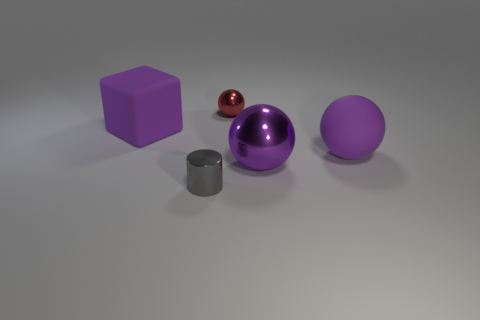What number of large purple objects are the same shape as the red metal thing?
Make the answer very short. 2. What is the thing left of the cylinder made of?
Your answer should be very brief. Rubber. There is a tiny metal thing behind the cylinder; is it the same shape as the big purple shiny object?
Offer a terse response. Yes. Are there any red metallic things that have the same size as the purple rubber ball?
Provide a short and direct response. No. There is a big metal thing; is its shape the same as the big purple thing that is left of the big metallic object?
Give a very brief answer. No. There is a large rubber object that is the same color as the block; what shape is it?
Your answer should be compact. Sphere. Is the number of small gray objects that are to the right of the large purple metal sphere less than the number of small brown matte spheres?
Your response must be concise. No. Does the red object have the same shape as the purple shiny object?
Offer a terse response. Yes. There is a gray object that is the same material as the red sphere; what size is it?
Your response must be concise. Small. Is the number of big metal objects less than the number of green rubber blocks?
Offer a very short reply. No. 